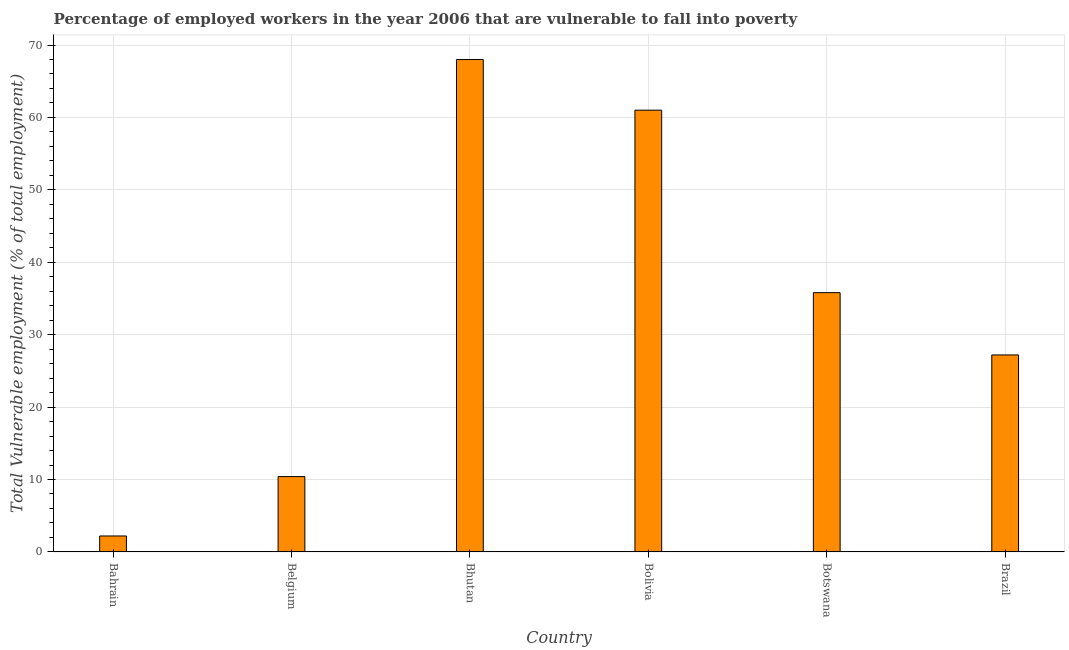Does the graph contain grids?
Ensure brevity in your answer.  Yes. What is the title of the graph?
Your answer should be very brief. Percentage of employed workers in the year 2006 that are vulnerable to fall into poverty. What is the label or title of the Y-axis?
Give a very brief answer. Total Vulnerable employment (% of total employment). Across all countries, what is the maximum total vulnerable employment?
Offer a terse response. 68. Across all countries, what is the minimum total vulnerable employment?
Your answer should be compact. 2.2. In which country was the total vulnerable employment maximum?
Offer a very short reply. Bhutan. In which country was the total vulnerable employment minimum?
Your response must be concise. Bahrain. What is the sum of the total vulnerable employment?
Give a very brief answer. 204.6. What is the difference between the total vulnerable employment in Belgium and Botswana?
Make the answer very short. -25.4. What is the average total vulnerable employment per country?
Give a very brief answer. 34.1. What is the median total vulnerable employment?
Give a very brief answer. 31.5. In how many countries, is the total vulnerable employment greater than 42 %?
Your response must be concise. 2. What is the ratio of the total vulnerable employment in Bolivia to that in Botswana?
Make the answer very short. 1.7. Is the difference between the total vulnerable employment in Bahrain and Bolivia greater than the difference between any two countries?
Your answer should be very brief. No. What is the difference between the highest and the lowest total vulnerable employment?
Offer a very short reply. 65.8. In how many countries, is the total vulnerable employment greater than the average total vulnerable employment taken over all countries?
Ensure brevity in your answer.  3. How many bars are there?
Offer a terse response. 6. Are the values on the major ticks of Y-axis written in scientific E-notation?
Your response must be concise. No. What is the Total Vulnerable employment (% of total employment) of Bahrain?
Offer a very short reply. 2.2. What is the Total Vulnerable employment (% of total employment) in Belgium?
Make the answer very short. 10.4. What is the Total Vulnerable employment (% of total employment) in Bolivia?
Your answer should be compact. 61. What is the Total Vulnerable employment (% of total employment) of Botswana?
Your answer should be very brief. 35.8. What is the Total Vulnerable employment (% of total employment) of Brazil?
Keep it short and to the point. 27.2. What is the difference between the Total Vulnerable employment (% of total employment) in Bahrain and Bhutan?
Your response must be concise. -65.8. What is the difference between the Total Vulnerable employment (% of total employment) in Bahrain and Bolivia?
Ensure brevity in your answer.  -58.8. What is the difference between the Total Vulnerable employment (% of total employment) in Bahrain and Botswana?
Offer a very short reply. -33.6. What is the difference between the Total Vulnerable employment (% of total employment) in Bahrain and Brazil?
Your answer should be very brief. -25. What is the difference between the Total Vulnerable employment (% of total employment) in Belgium and Bhutan?
Offer a very short reply. -57.6. What is the difference between the Total Vulnerable employment (% of total employment) in Belgium and Bolivia?
Give a very brief answer. -50.6. What is the difference between the Total Vulnerable employment (% of total employment) in Belgium and Botswana?
Provide a succinct answer. -25.4. What is the difference between the Total Vulnerable employment (% of total employment) in Belgium and Brazil?
Provide a succinct answer. -16.8. What is the difference between the Total Vulnerable employment (% of total employment) in Bhutan and Bolivia?
Your answer should be compact. 7. What is the difference between the Total Vulnerable employment (% of total employment) in Bhutan and Botswana?
Provide a short and direct response. 32.2. What is the difference between the Total Vulnerable employment (% of total employment) in Bhutan and Brazil?
Keep it short and to the point. 40.8. What is the difference between the Total Vulnerable employment (% of total employment) in Bolivia and Botswana?
Offer a terse response. 25.2. What is the difference between the Total Vulnerable employment (% of total employment) in Bolivia and Brazil?
Ensure brevity in your answer.  33.8. What is the difference between the Total Vulnerable employment (% of total employment) in Botswana and Brazil?
Offer a very short reply. 8.6. What is the ratio of the Total Vulnerable employment (% of total employment) in Bahrain to that in Belgium?
Give a very brief answer. 0.21. What is the ratio of the Total Vulnerable employment (% of total employment) in Bahrain to that in Bhutan?
Keep it short and to the point. 0.03. What is the ratio of the Total Vulnerable employment (% of total employment) in Bahrain to that in Bolivia?
Your answer should be compact. 0.04. What is the ratio of the Total Vulnerable employment (% of total employment) in Bahrain to that in Botswana?
Ensure brevity in your answer.  0.06. What is the ratio of the Total Vulnerable employment (% of total employment) in Bahrain to that in Brazil?
Keep it short and to the point. 0.08. What is the ratio of the Total Vulnerable employment (% of total employment) in Belgium to that in Bhutan?
Give a very brief answer. 0.15. What is the ratio of the Total Vulnerable employment (% of total employment) in Belgium to that in Bolivia?
Provide a succinct answer. 0.17. What is the ratio of the Total Vulnerable employment (% of total employment) in Belgium to that in Botswana?
Your response must be concise. 0.29. What is the ratio of the Total Vulnerable employment (% of total employment) in Belgium to that in Brazil?
Provide a short and direct response. 0.38. What is the ratio of the Total Vulnerable employment (% of total employment) in Bhutan to that in Bolivia?
Provide a succinct answer. 1.11. What is the ratio of the Total Vulnerable employment (% of total employment) in Bhutan to that in Botswana?
Provide a short and direct response. 1.9. What is the ratio of the Total Vulnerable employment (% of total employment) in Bhutan to that in Brazil?
Ensure brevity in your answer.  2.5. What is the ratio of the Total Vulnerable employment (% of total employment) in Bolivia to that in Botswana?
Provide a short and direct response. 1.7. What is the ratio of the Total Vulnerable employment (% of total employment) in Bolivia to that in Brazil?
Keep it short and to the point. 2.24. What is the ratio of the Total Vulnerable employment (% of total employment) in Botswana to that in Brazil?
Your answer should be compact. 1.32. 